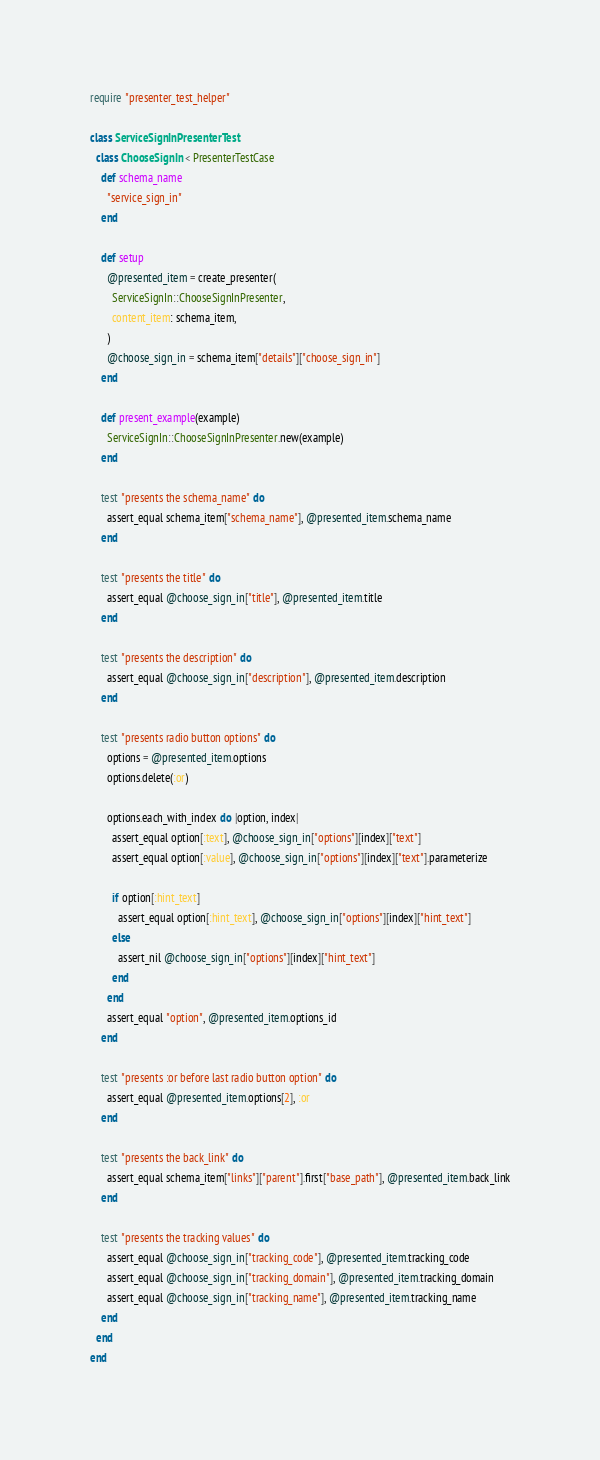<code> <loc_0><loc_0><loc_500><loc_500><_Ruby_>require "presenter_test_helper"

class ServiceSignInPresenterTest
  class ChooseSignIn < PresenterTestCase
    def schema_name
      "service_sign_in"
    end

    def setup
      @presented_item = create_presenter(
        ServiceSignIn::ChooseSignInPresenter,
        content_item: schema_item,
      )
      @choose_sign_in = schema_item["details"]["choose_sign_in"]
    end

    def present_example(example)
      ServiceSignIn::ChooseSignInPresenter.new(example)
    end

    test "presents the schema_name" do
      assert_equal schema_item["schema_name"], @presented_item.schema_name
    end

    test "presents the title" do
      assert_equal @choose_sign_in["title"], @presented_item.title
    end

    test "presents the description" do
      assert_equal @choose_sign_in["description"], @presented_item.description
    end

    test "presents radio button options" do
      options = @presented_item.options
      options.delete(:or)

      options.each_with_index do |option, index|
        assert_equal option[:text], @choose_sign_in["options"][index]["text"]
        assert_equal option[:value], @choose_sign_in["options"][index]["text"].parameterize

        if option[:hint_text]
          assert_equal option[:hint_text], @choose_sign_in["options"][index]["hint_text"]
        else
          assert_nil @choose_sign_in["options"][index]["hint_text"]
        end
      end
      assert_equal "option", @presented_item.options_id
    end

    test "presents :or before last radio button option" do
      assert_equal @presented_item.options[2], :or
    end

    test "presents the back_link" do
      assert_equal schema_item["links"]["parent"].first["base_path"], @presented_item.back_link
    end

    test "presents the tracking values" do
      assert_equal @choose_sign_in["tracking_code"], @presented_item.tracking_code
      assert_equal @choose_sign_in["tracking_domain"], @presented_item.tracking_domain
      assert_equal @choose_sign_in["tracking_name"], @presented_item.tracking_name
    end
  end
end
</code> 